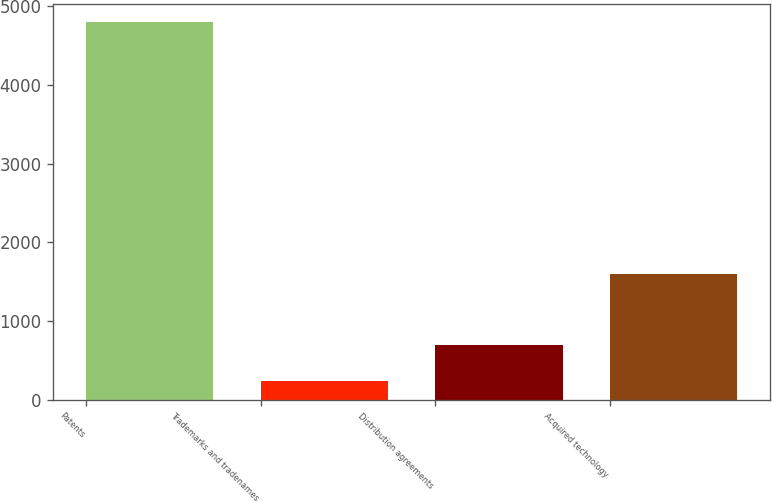Convert chart. <chart><loc_0><loc_0><loc_500><loc_500><bar_chart><fcel>Patents<fcel>Trademarks and tradenames<fcel>Distribution agreements<fcel>Acquired technology<nl><fcel>4792<fcel>236<fcel>691.6<fcel>1596<nl></chart> 